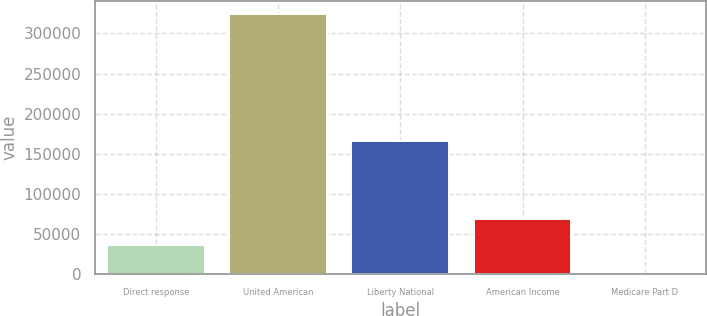<chart> <loc_0><loc_0><loc_500><loc_500><bar_chart><fcel>Direct response<fcel>United American<fcel>Liberty National<fcel>American Income<fcel>Medicare Part D<nl><fcel>36550<fcel>324467<fcel>165445<fcel>68996.3<fcel>4.22<nl></chart> 